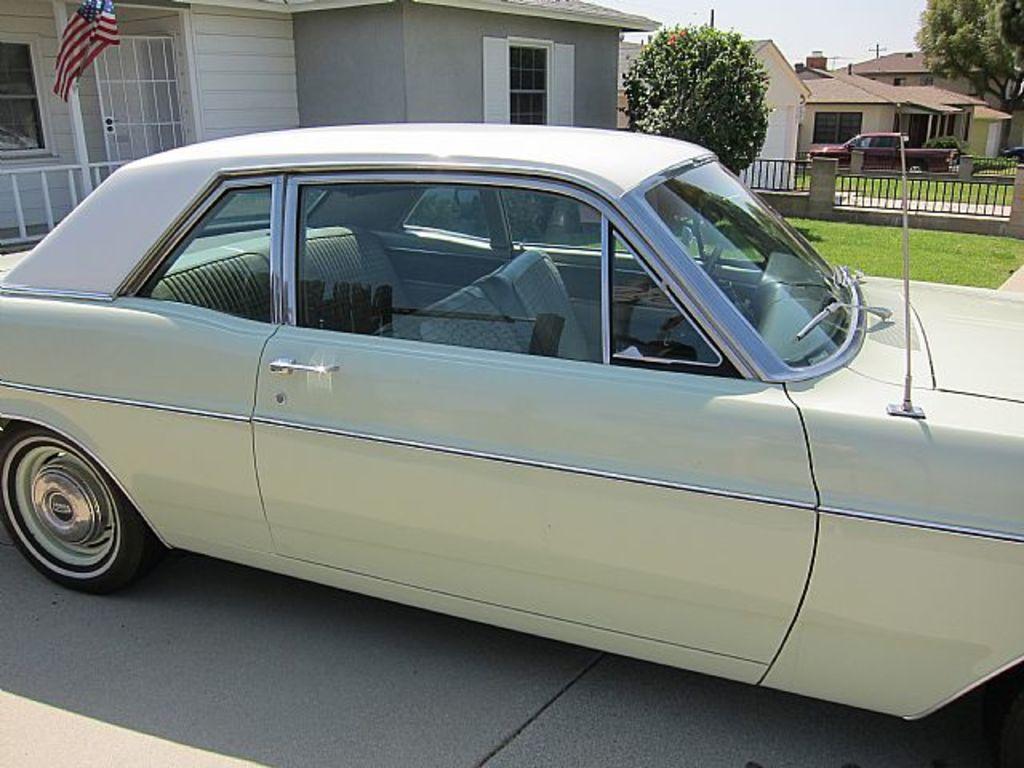In one or two sentences, can you explain what this image depicts? In this image I see number of buildings and I see the flag over here which is of white, red and blue in color and I see 2 cars and I see the green grass and I see 2 trees. In the background I see the sky and I see the path over here. 